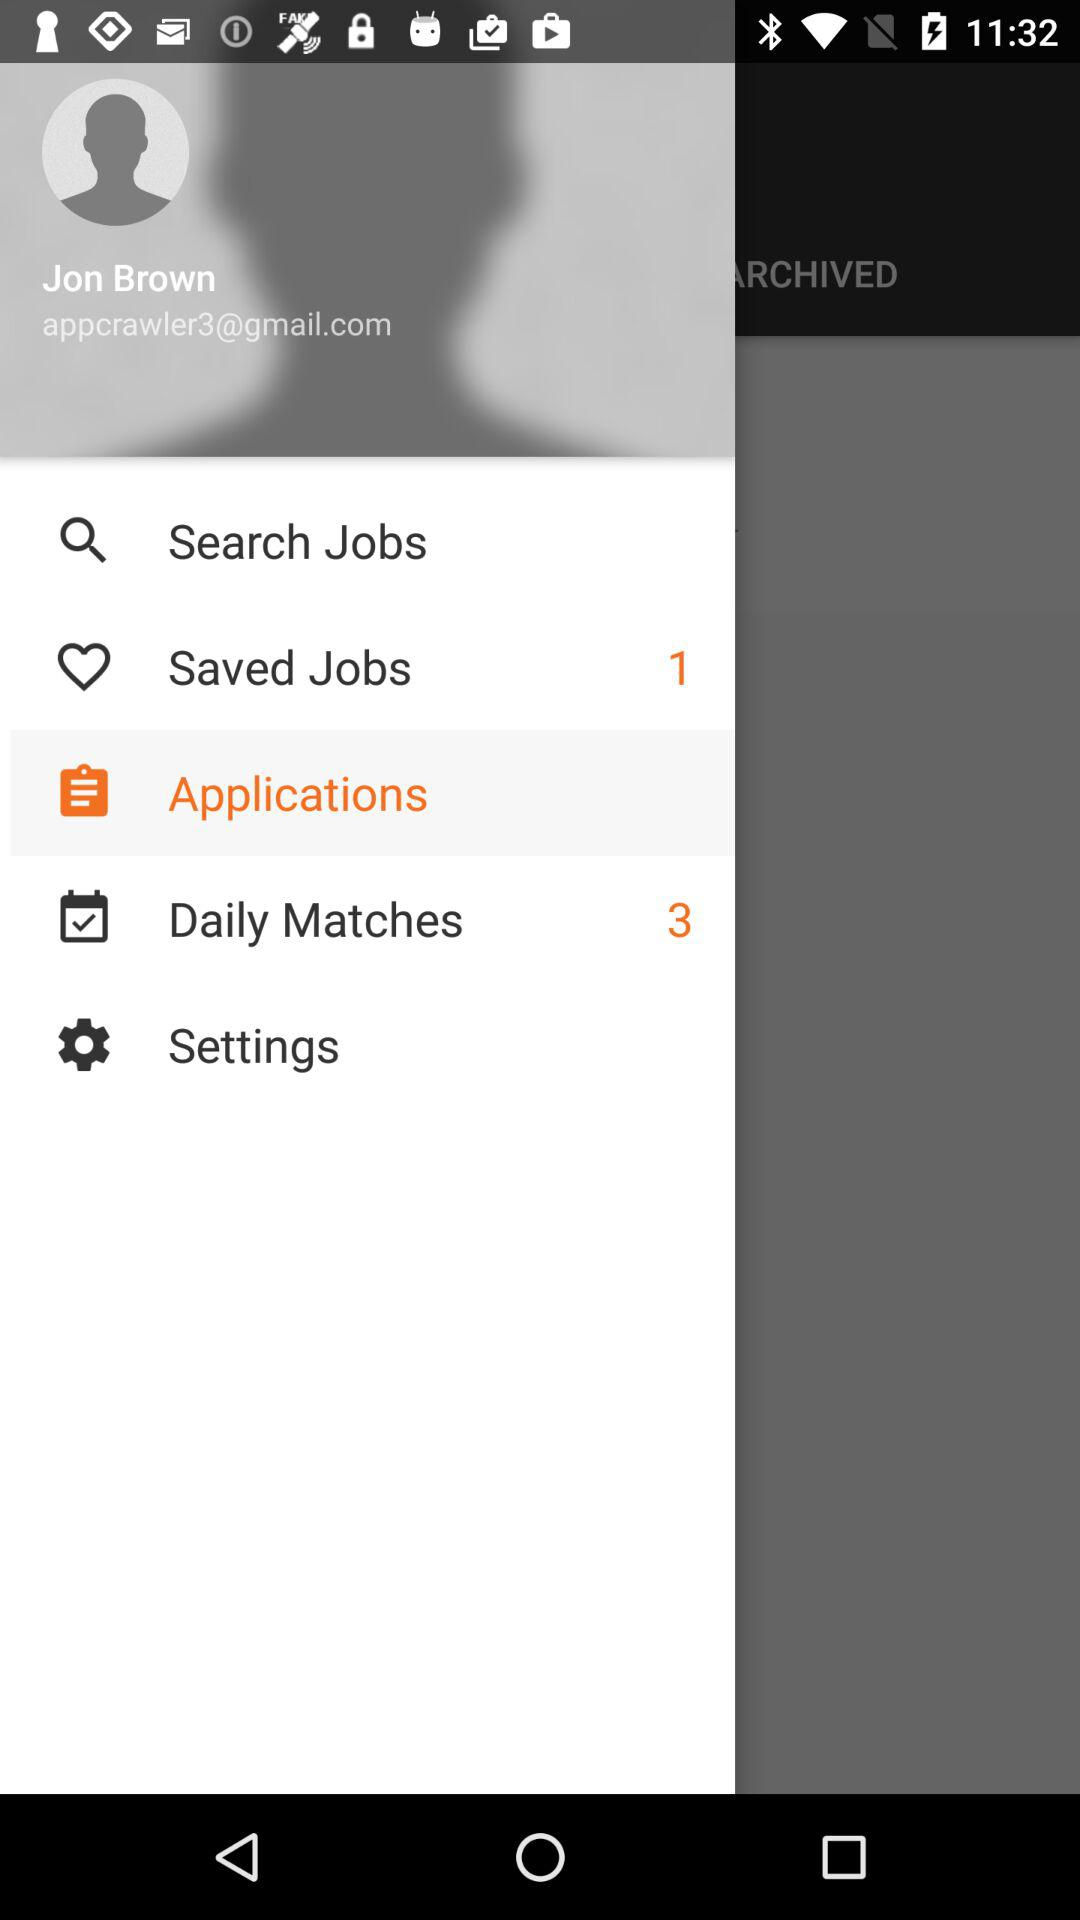What is the selected option? The selected option is "Applications". 